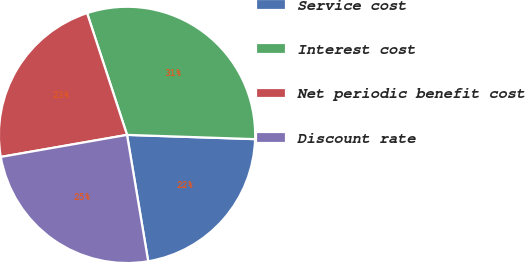Convert chart to OTSL. <chart><loc_0><loc_0><loc_500><loc_500><pie_chart><fcel>Service cost<fcel>Interest cost<fcel>Net periodic benefit cost<fcel>Discount rate<nl><fcel>21.83%<fcel>30.57%<fcel>22.71%<fcel>24.89%<nl></chart> 